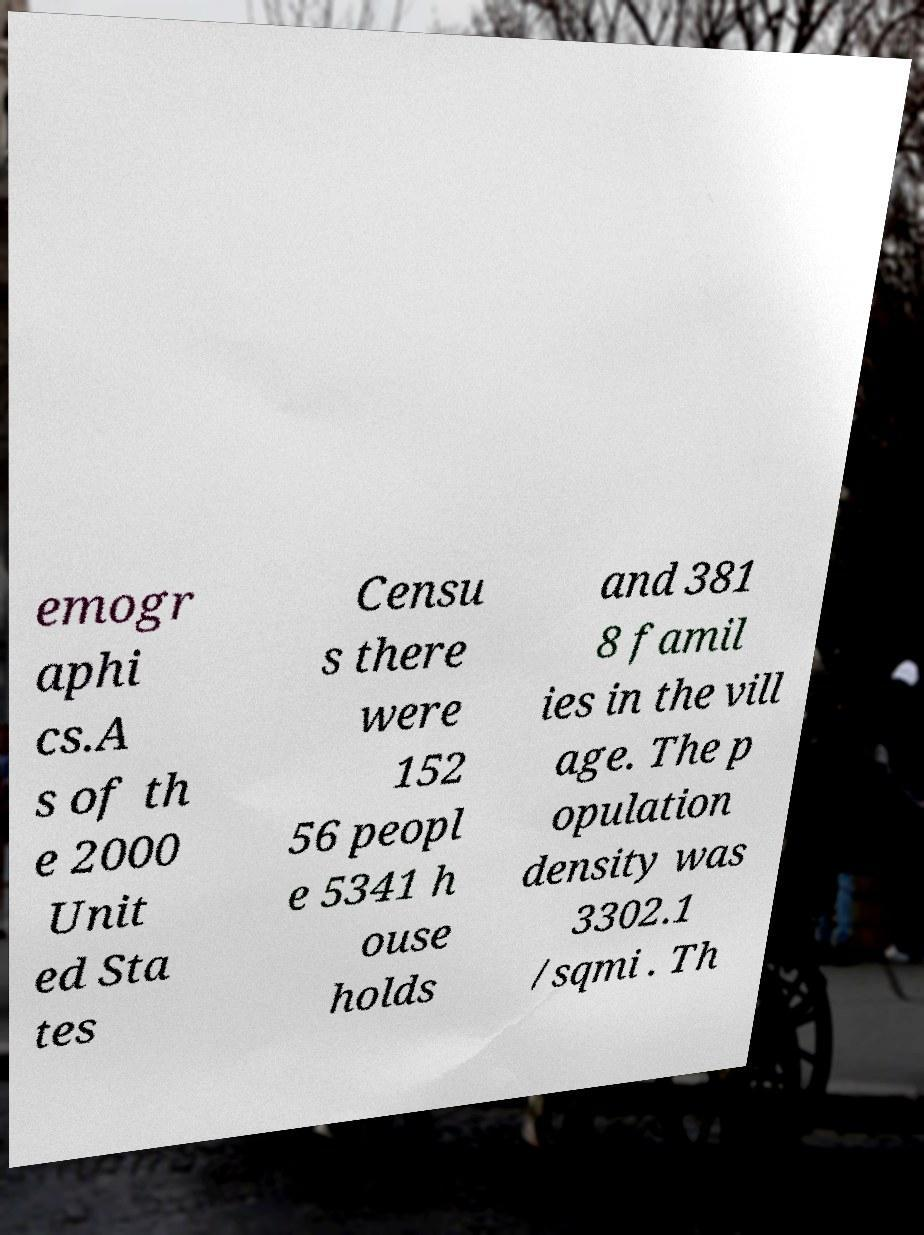Could you assist in decoding the text presented in this image and type it out clearly? emogr aphi cs.A s of th e 2000 Unit ed Sta tes Censu s there were 152 56 peopl e 5341 h ouse holds and 381 8 famil ies in the vill age. The p opulation density was 3302.1 /sqmi . Th 